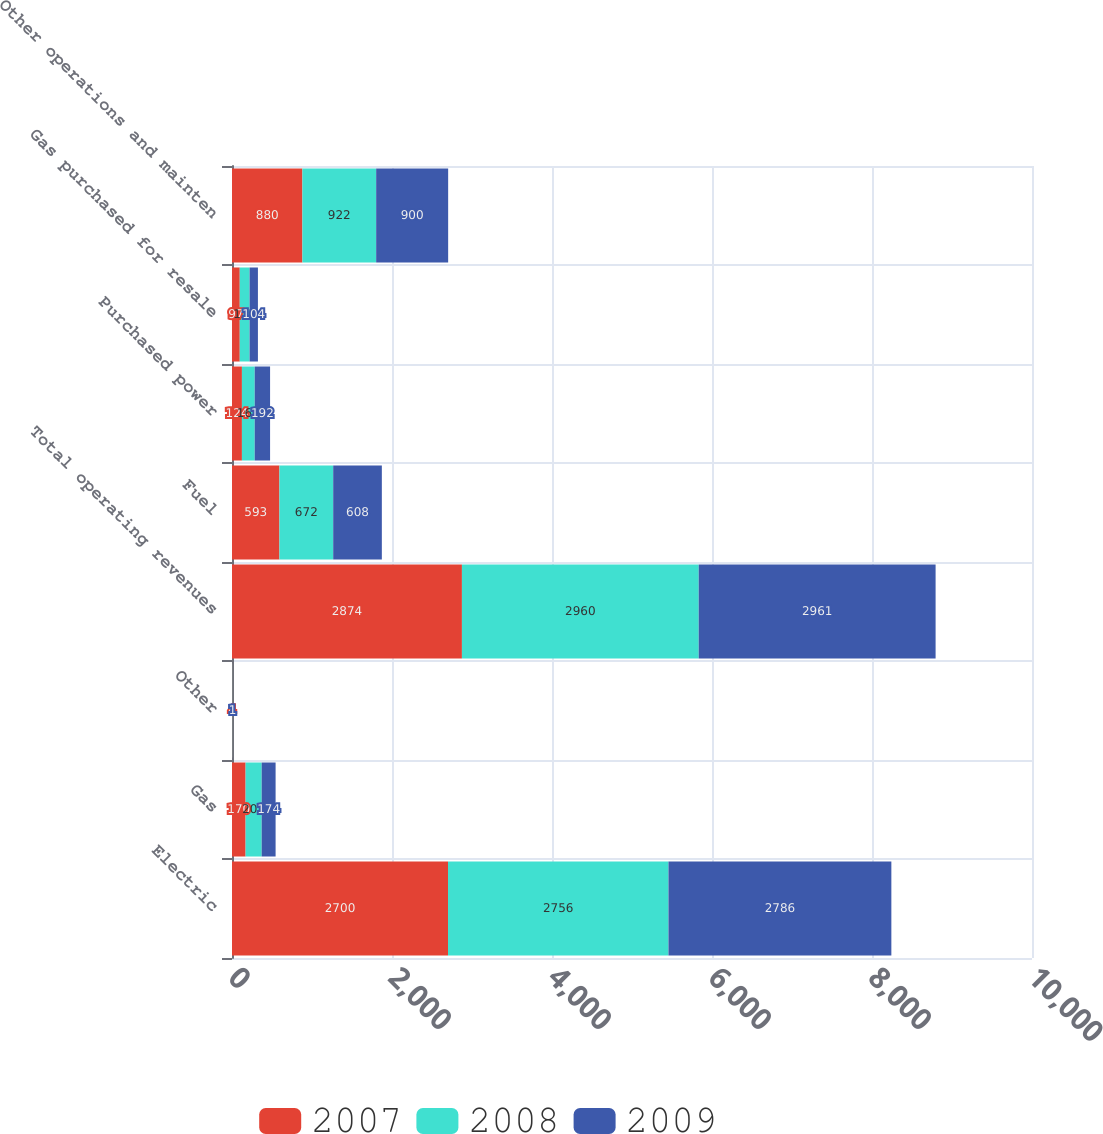Convert chart to OTSL. <chart><loc_0><loc_0><loc_500><loc_500><stacked_bar_chart><ecel><fcel>Electric<fcel>Gas<fcel>Other<fcel>Total operating revenues<fcel>Fuel<fcel>Purchased power<fcel>Gas purchased for resale<fcel>Other operations and mainten<nl><fcel>2007<fcel>2700<fcel>170<fcel>4<fcel>2874<fcel>593<fcel>124<fcel>97<fcel>880<nl><fcel>2008<fcel>2756<fcel>201<fcel>3<fcel>2960<fcel>672<fcel>160<fcel>123<fcel>922<nl><fcel>2009<fcel>2786<fcel>174<fcel>1<fcel>2961<fcel>608<fcel>192<fcel>104<fcel>900<nl></chart> 